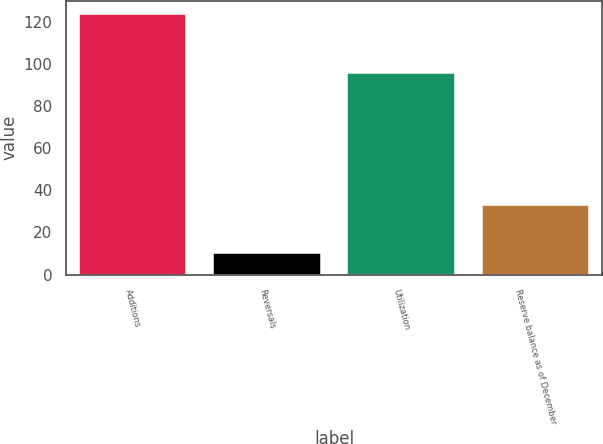Convert chart to OTSL. <chart><loc_0><loc_0><loc_500><loc_500><bar_chart><fcel>Additions<fcel>Reversals<fcel>Utilization<fcel>Reserve balance as of December<nl><fcel>124<fcel>10<fcel>96<fcel>33<nl></chart> 